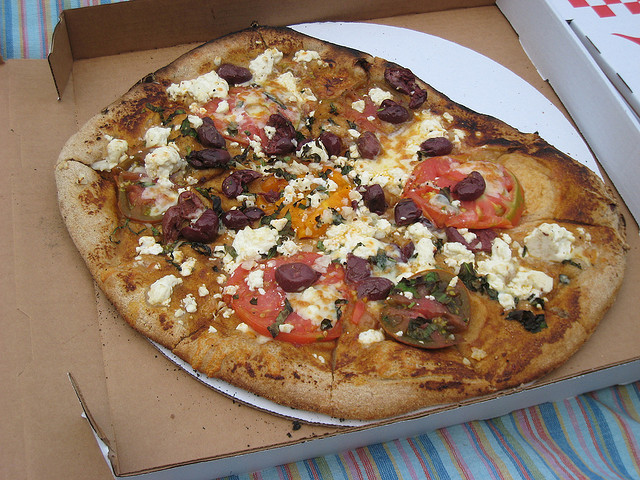<image>What meat is on the top? It is ambiguous what meat is on the top. It could be pepperoni or sausage, or there might be no meat at all. What meat is on the top? I am not sure what meat is on the top. It can be seen 'pepperoni', 'sausage' or 'no meat'. 